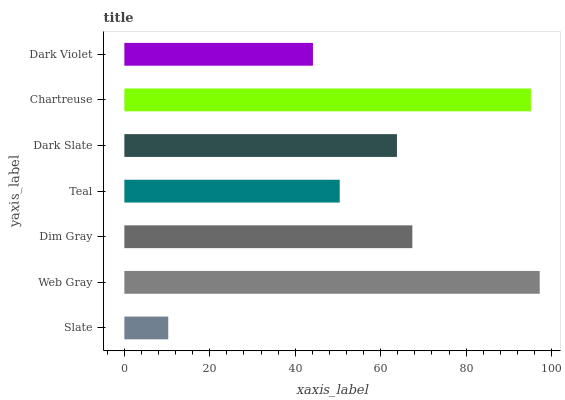Is Slate the minimum?
Answer yes or no. Yes. Is Web Gray the maximum?
Answer yes or no. Yes. Is Dim Gray the minimum?
Answer yes or no. No. Is Dim Gray the maximum?
Answer yes or no. No. Is Web Gray greater than Dim Gray?
Answer yes or no. Yes. Is Dim Gray less than Web Gray?
Answer yes or no. Yes. Is Dim Gray greater than Web Gray?
Answer yes or no. No. Is Web Gray less than Dim Gray?
Answer yes or no. No. Is Dark Slate the high median?
Answer yes or no. Yes. Is Dark Slate the low median?
Answer yes or no. Yes. Is Chartreuse the high median?
Answer yes or no. No. Is Slate the low median?
Answer yes or no. No. 